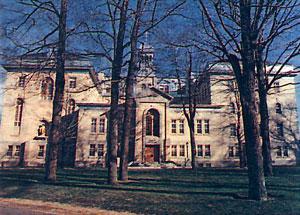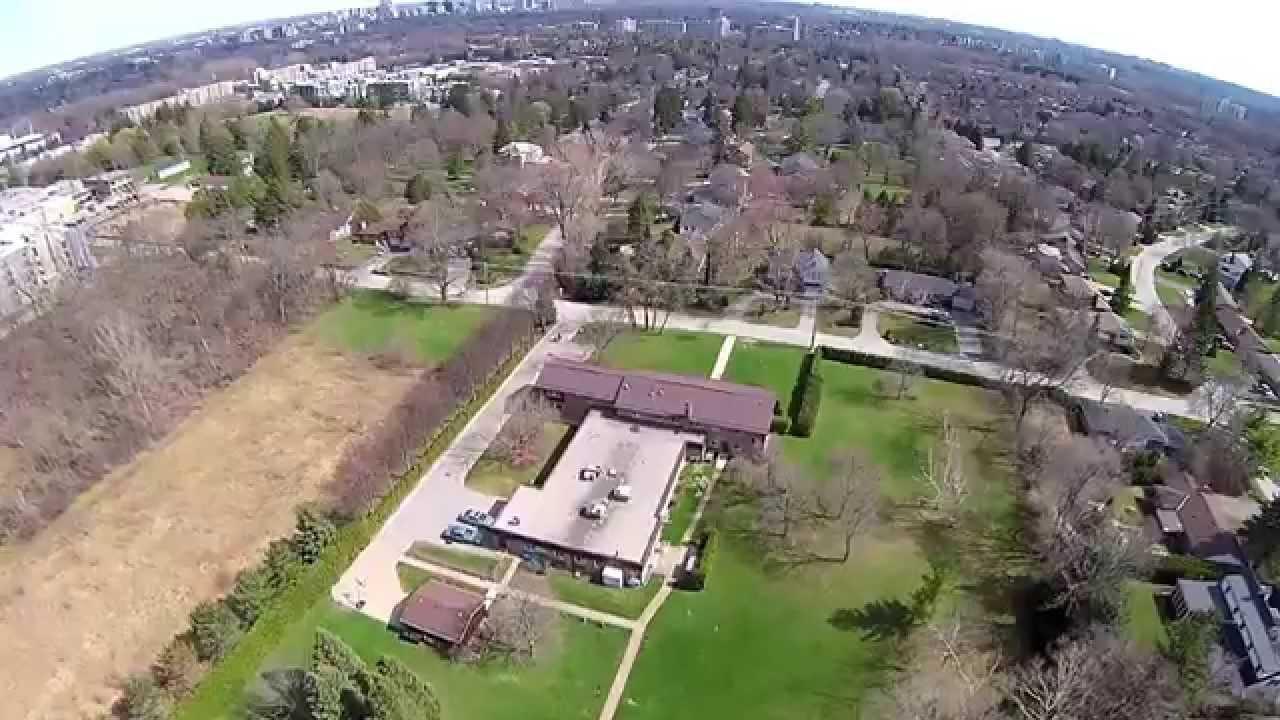The first image is the image on the left, the second image is the image on the right. Considering the images on both sides, is "Each image includes a woman wearing red and white and a woman wearing a black-and-white head covering, and the left image contains two people, while the right image contains three people." valid? Answer yes or no. No. The first image is the image on the left, the second image is the image on the right. Examine the images to the left and right. Is the description "There are women and no men." accurate? Answer yes or no. No. 